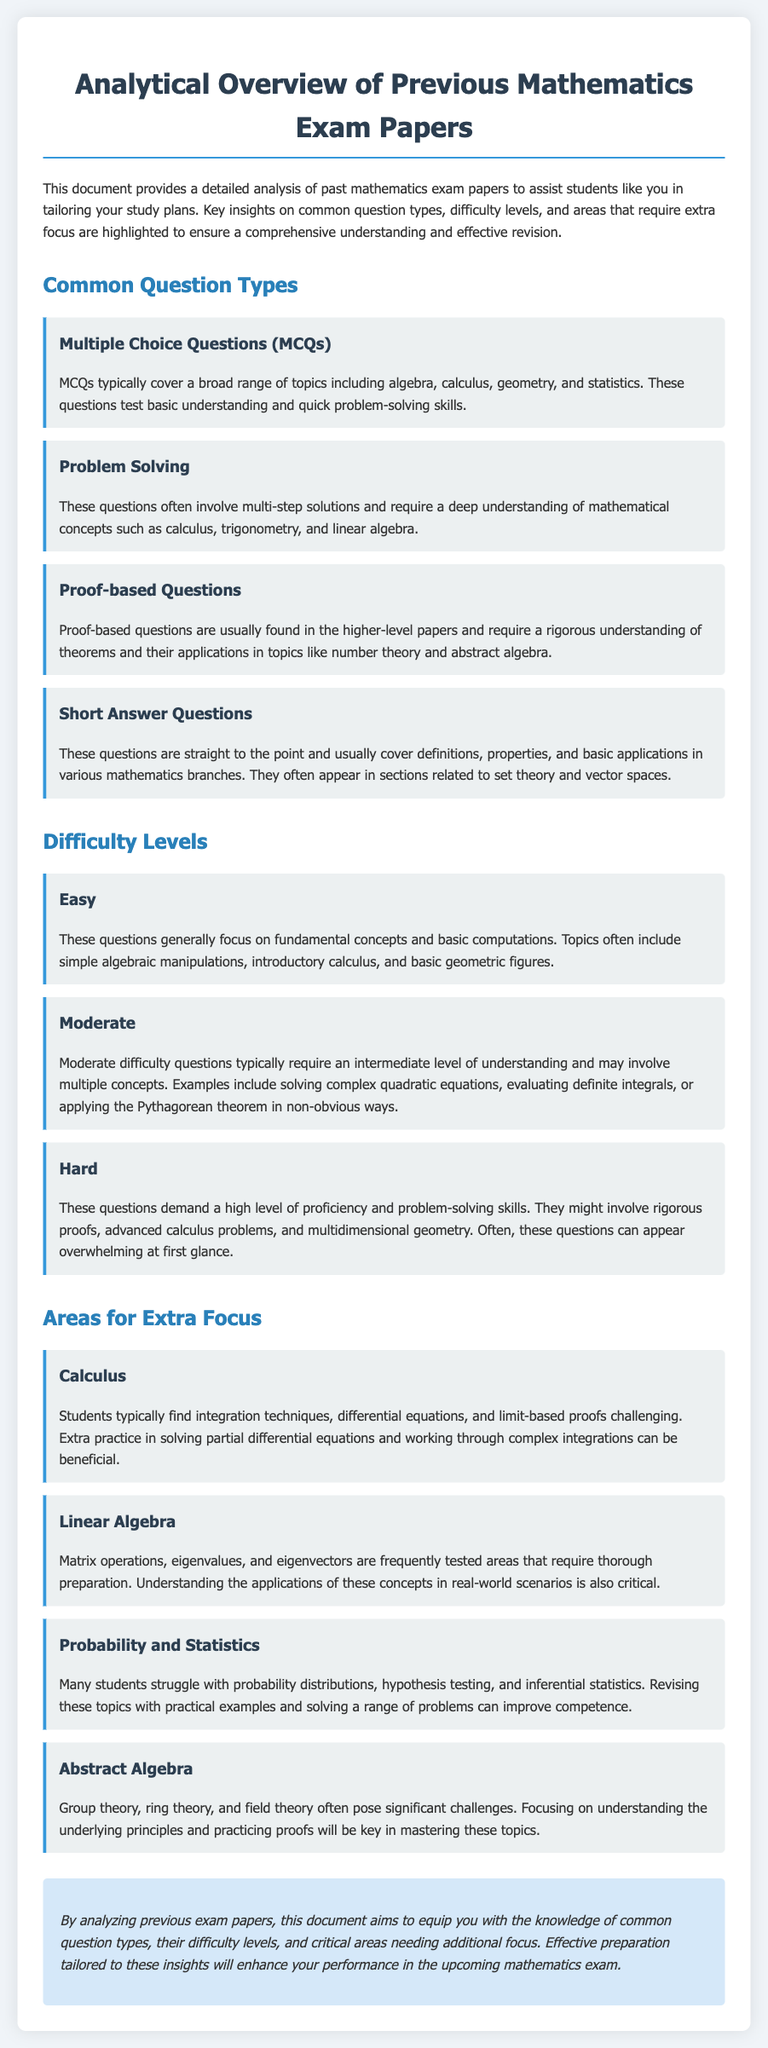What are the common question types in mathematics exams? The document lists the common question types, which include Multiple Choice Questions, Problem Solving, Proof-based Questions, and Short Answer Questions.
Answer: Multiple Choice Questions, Problem Solving, Proof-based Questions, Short Answer Questions What is a key area that requires extra focus according to the document? The document highlights several areas for extra focus, including Calculus, Linear Algebra, Probability and Statistics, and Abstract Algebra.
Answer: Calculus What type of question is characterized by multi-step solutions? According to the document, Problem Solving questions typically involve multi-step solutions.
Answer: Problem Solving What is the difficulty level associated with fundamental concepts and basic computations? The document categorizes Easy questions as focusing on fundamental concepts and basic computations.
Answer: Easy What concept in Linear Algebra is frequently tested? The document states that matrix operations are a frequently tested area in Linear Algebra.
Answer: Matrix operations What does the document suggest to improve competence in Probability and Statistics? The document recommends revising topics with practical examples and solving a range of problems for better understanding in Probability and Statistics.
Answer: Practical examples and solving a range of problems What question type requires a rigorous understanding of theorems? The document mentions that Proof-based Questions require a rigorous understanding of theorems.
Answer: Proof-based Questions What is the conclusion about effective preparation in mathematics exams? The document concludes that tailored preparation based on the insights from previous exam papers will enhance performance.
Answer: Enhance performance 